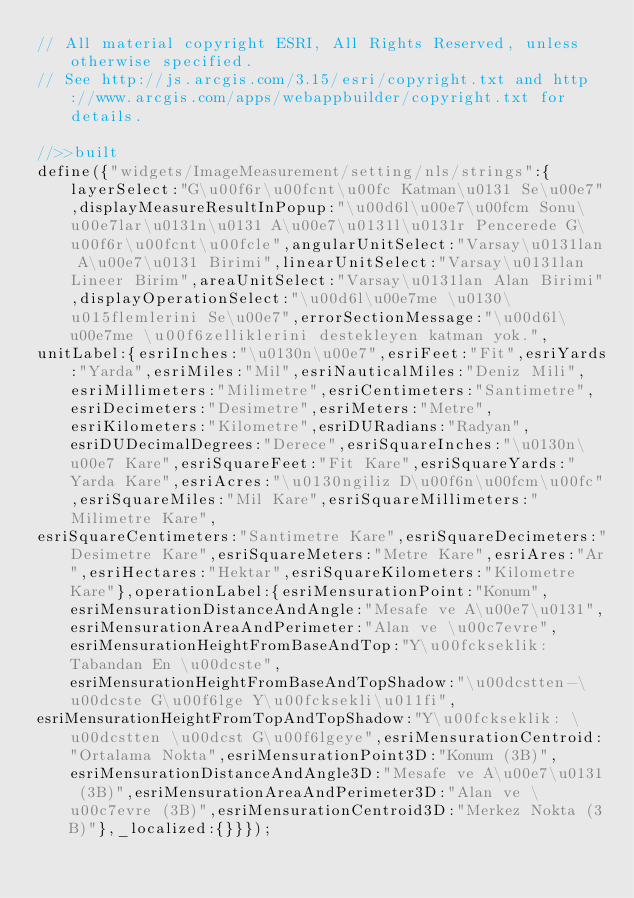Convert code to text. <code><loc_0><loc_0><loc_500><loc_500><_JavaScript_>// All material copyright ESRI, All Rights Reserved, unless otherwise specified.
// See http://js.arcgis.com/3.15/esri/copyright.txt and http://www.arcgis.com/apps/webappbuilder/copyright.txt for details.
//>>built
define({"widgets/ImageMeasurement/setting/nls/strings":{layerSelect:"G\u00f6r\u00fcnt\u00fc Katman\u0131 Se\u00e7",displayMeasureResultInPopup:"\u00d6l\u00e7\u00fcm Sonu\u00e7lar\u0131n\u0131 A\u00e7\u0131l\u0131r Pencerede G\u00f6r\u00fcnt\u00fcle",angularUnitSelect:"Varsay\u0131lan A\u00e7\u0131 Birimi",linearUnitSelect:"Varsay\u0131lan Lineer Birim",areaUnitSelect:"Varsay\u0131lan Alan Birimi",displayOperationSelect:"\u00d6l\u00e7me \u0130\u015flemlerini Se\u00e7",errorSectionMessage:"\u00d6l\u00e7me \u00f6zelliklerini destekleyen katman yok.",
unitLabel:{esriInches:"\u0130n\u00e7",esriFeet:"Fit",esriYards:"Yarda",esriMiles:"Mil",esriNauticalMiles:"Deniz Mili",esriMillimeters:"Milimetre",esriCentimeters:"Santimetre",esriDecimeters:"Desimetre",esriMeters:"Metre",esriKilometers:"Kilometre",esriDURadians:"Radyan",esriDUDecimalDegrees:"Derece",esriSquareInches:"\u0130n\u00e7 Kare",esriSquareFeet:"Fit Kare",esriSquareYards:"Yarda Kare",esriAcres:"\u0130ngiliz D\u00f6n\u00fcm\u00fc",esriSquareMiles:"Mil Kare",esriSquareMillimeters:"Milimetre Kare",
esriSquareCentimeters:"Santimetre Kare",esriSquareDecimeters:"Desimetre Kare",esriSquareMeters:"Metre Kare",esriAres:"Ar",esriHectares:"Hektar",esriSquareKilometers:"Kilometre Kare"},operationLabel:{esriMensurationPoint:"Konum",esriMensurationDistanceAndAngle:"Mesafe ve A\u00e7\u0131",esriMensurationAreaAndPerimeter:"Alan ve \u00c7evre",esriMensurationHeightFromBaseAndTop:"Y\u00fckseklik: Tabandan En \u00dcste",esriMensurationHeightFromBaseAndTopShadow:"\u00dcstten-\u00dcste G\u00f6lge Y\u00fcksekli\u011fi",
esriMensurationHeightFromTopAndTopShadow:"Y\u00fckseklik: \u00dcstten \u00dcst G\u00f6lgeye",esriMensurationCentroid:"Ortalama Nokta",esriMensurationPoint3D:"Konum (3B)",esriMensurationDistanceAndAngle3D:"Mesafe ve A\u00e7\u0131 (3B)",esriMensurationAreaAndPerimeter3D:"Alan ve \u00c7evre (3B)",esriMensurationCentroid3D:"Merkez Nokta (3B)"},_localized:{}}});</code> 